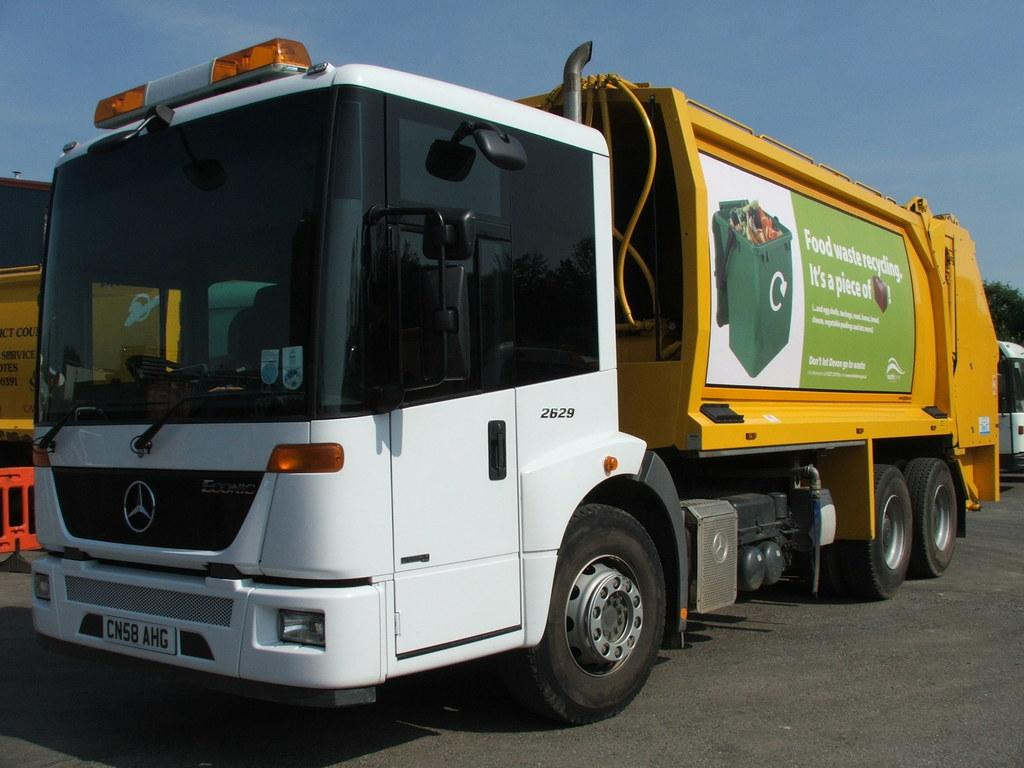<image>
Give a short and clear explanation of the subsequent image. A garbage truck advertisement encourages attention to the issue of food waste recycling. 